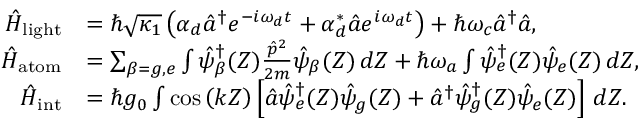<formula> <loc_0><loc_0><loc_500><loc_500>\begin{array} { r l } { \hat { H } _ { l i g h t } } & { = \hbar { \sqrt } { \kappa _ { 1 } } \left ( \alpha _ { d } \hat { a } ^ { \dagger } e ^ { - i \omega _ { d } t } + \alpha _ { d } ^ { * } \hat { a } e ^ { i \omega _ { d } t } \right ) + \hbar { \omega } _ { c } \hat { a } ^ { \dagger } \hat { a } , } \\ { \hat { H } _ { a t o m } } & { = \sum _ { \beta = g , e } \int \hat { \psi } _ { \beta } ^ { \dagger } ( Z ) \frac { \hat { p } ^ { 2 } } { 2 m } \hat { \psi } _ { \beta } ( Z ) \, d Z + \hbar { \omega } _ { a } \int \hat { \psi } _ { e } ^ { \dagger } ( Z ) \hat { \psi } _ { e } ( Z ) \, d Z , } \\ { \hat { H } _ { i n t } } & { = \hbar { g } _ { 0 } \int \cos \left ( k Z \right ) \left [ \hat { a } \hat { \psi } _ { e } ^ { \dagger } ( Z ) \hat { \psi } _ { g } ( Z ) + \hat { a } ^ { \dagger } \hat { \psi } _ { g } ^ { \dagger } ( Z ) \hat { \psi } _ { e } ( Z ) \right ] \, d Z . } \end{array}</formula> 